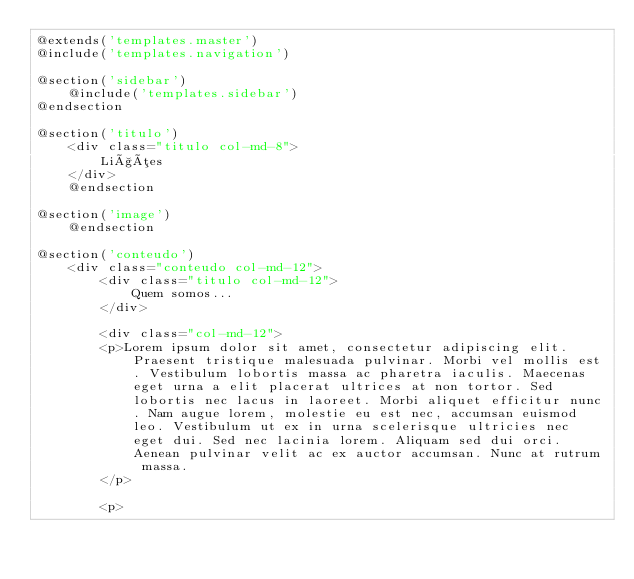<code> <loc_0><loc_0><loc_500><loc_500><_PHP_>@extends('templates.master')
@include('templates.navigation')

@section('sidebar')
    @include('templates.sidebar')
@endsection

@section('titulo')
    <div class="titulo col-md-8">
        Lições
    </div>
    @endsection

@section('image')
    @endsection

@section('conteudo')
    <div class="conteudo col-md-12">
        <div class="titulo col-md-12">
            Quem somos...
        </div>

        <div class="col-md-12">
        <p>Lorem ipsum dolor sit amet, consectetur adipiscing elit. Praesent tristique malesuada pulvinar. Morbi vel mollis est. Vestibulum lobortis massa ac pharetra iaculis. Maecenas eget urna a elit placerat ultrices at non tortor. Sed lobortis nec lacus in laoreet. Morbi aliquet efficitur nunc. Nam augue lorem, molestie eu est nec, accumsan euismod leo. Vestibulum ut ex in urna scelerisque ultricies nec eget dui. Sed nec lacinia lorem. Aliquam sed dui orci. Aenean pulvinar velit ac ex auctor accumsan. Nunc at rutrum massa.
        </p>

        <p></code> 